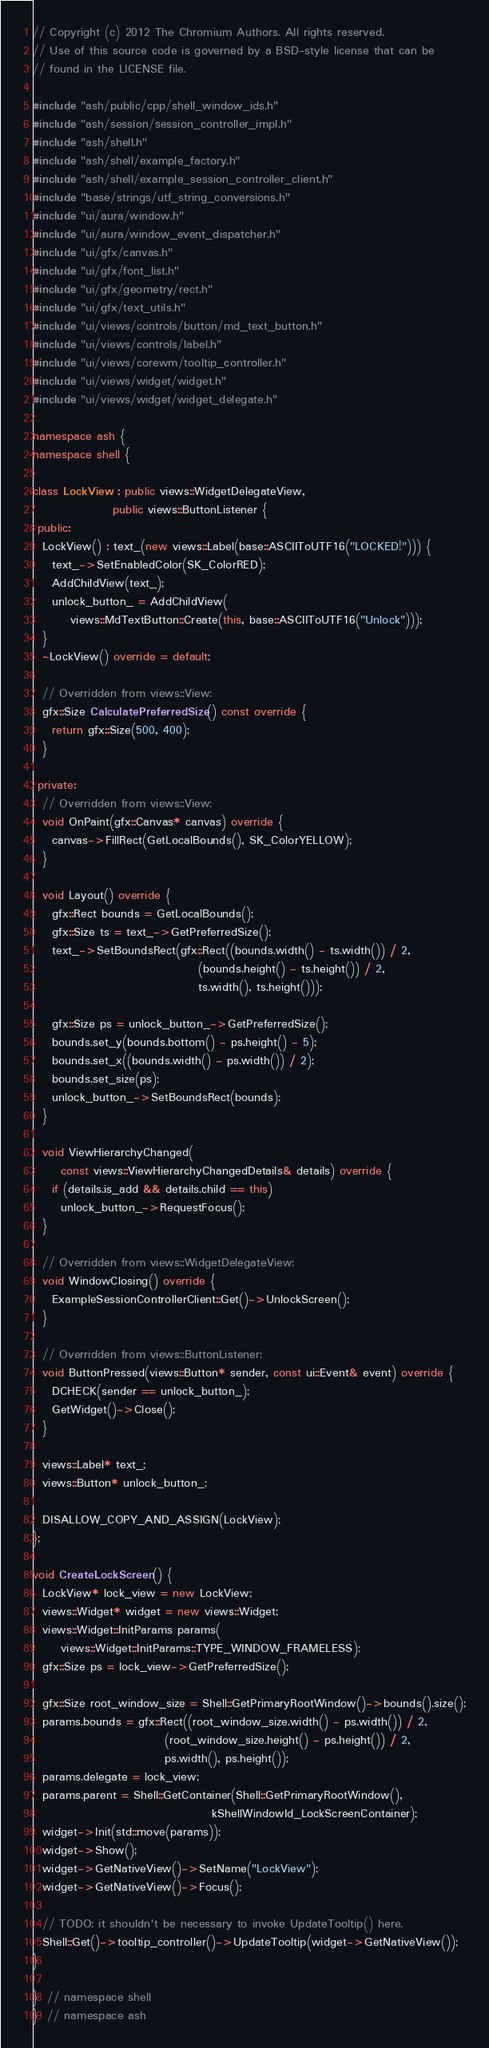<code> <loc_0><loc_0><loc_500><loc_500><_C++_>// Copyright (c) 2012 The Chromium Authors. All rights reserved.
// Use of this source code is governed by a BSD-style license that can be
// found in the LICENSE file.

#include "ash/public/cpp/shell_window_ids.h"
#include "ash/session/session_controller_impl.h"
#include "ash/shell.h"
#include "ash/shell/example_factory.h"
#include "ash/shell/example_session_controller_client.h"
#include "base/strings/utf_string_conversions.h"
#include "ui/aura/window.h"
#include "ui/aura/window_event_dispatcher.h"
#include "ui/gfx/canvas.h"
#include "ui/gfx/font_list.h"
#include "ui/gfx/geometry/rect.h"
#include "ui/gfx/text_utils.h"
#include "ui/views/controls/button/md_text_button.h"
#include "ui/views/controls/label.h"
#include "ui/views/corewm/tooltip_controller.h"
#include "ui/views/widget/widget.h"
#include "ui/views/widget/widget_delegate.h"

namespace ash {
namespace shell {

class LockView : public views::WidgetDelegateView,
                 public views::ButtonListener {
 public:
  LockView() : text_(new views::Label(base::ASCIIToUTF16("LOCKED!"))) {
    text_->SetEnabledColor(SK_ColorRED);
    AddChildView(text_);
    unlock_button_ = AddChildView(
        views::MdTextButton::Create(this, base::ASCIIToUTF16("Unlock")));
  }
  ~LockView() override = default;

  // Overridden from views::View:
  gfx::Size CalculatePreferredSize() const override {
    return gfx::Size(500, 400);
  }

 private:
  // Overridden from views::View:
  void OnPaint(gfx::Canvas* canvas) override {
    canvas->FillRect(GetLocalBounds(), SK_ColorYELLOW);
  }

  void Layout() override {
    gfx::Rect bounds = GetLocalBounds();
    gfx::Size ts = text_->GetPreferredSize();
    text_->SetBoundsRect(gfx::Rect((bounds.width() - ts.width()) / 2,
                                   (bounds.height() - ts.height()) / 2,
                                   ts.width(), ts.height()));

    gfx::Size ps = unlock_button_->GetPreferredSize();
    bounds.set_y(bounds.bottom() - ps.height() - 5);
    bounds.set_x((bounds.width() - ps.width()) / 2);
    bounds.set_size(ps);
    unlock_button_->SetBoundsRect(bounds);
  }

  void ViewHierarchyChanged(
      const views::ViewHierarchyChangedDetails& details) override {
    if (details.is_add && details.child == this)
      unlock_button_->RequestFocus();
  }

  // Overridden from views::WidgetDelegateView:
  void WindowClosing() override {
    ExampleSessionControllerClient::Get()->UnlockScreen();
  }

  // Overridden from views::ButtonListener:
  void ButtonPressed(views::Button* sender, const ui::Event& event) override {
    DCHECK(sender == unlock_button_);
    GetWidget()->Close();
  }

  views::Label* text_;
  views::Button* unlock_button_;

  DISALLOW_COPY_AND_ASSIGN(LockView);
};

void CreateLockScreen() {
  LockView* lock_view = new LockView;
  views::Widget* widget = new views::Widget;
  views::Widget::InitParams params(
      views::Widget::InitParams::TYPE_WINDOW_FRAMELESS);
  gfx::Size ps = lock_view->GetPreferredSize();

  gfx::Size root_window_size = Shell::GetPrimaryRootWindow()->bounds().size();
  params.bounds = gfx::Rect((root_window_size.width() - ps.width()) / 2,
                            (root_window_size.height() - ps.height()) / 2,
                            ps.width(), ps.height());
  params.delegate = lock_view;
  params.parent = Shell::GetContainer(Shell::GetPrimaryRootWindow(),
                                      kShellWindowId_LockScreenContainer);
  widget->Init(std::move(params));
  widget->Show();
  widget->GetNativeView()->SetName("LockView");
  widget->GetNativeView()->Focus();

  // TODO: it shouldn't be necessary to invoke UpdateTooltip() here.
  Shell::Get()->tooltip_controller()->UpdateTooltip(widget->GetNativeView());
}

}  // namespace shell
}  // namespace ash
</code> 